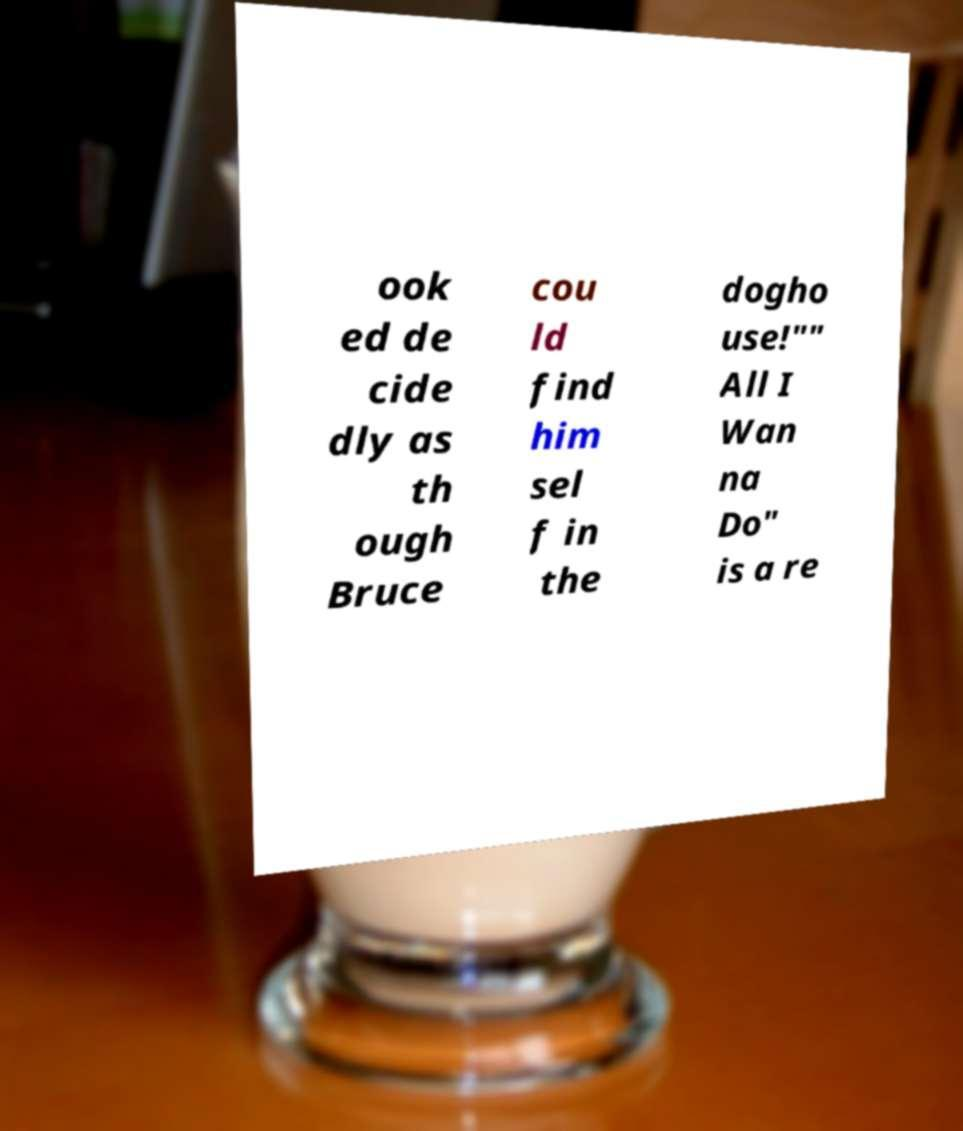Could you assist in decoding the text presented in this image and type it out clearly? ook ed de cide dly as th ough Bruce cou ld find him sel f in the dogho use!"" All I Wan na Do" is a re 